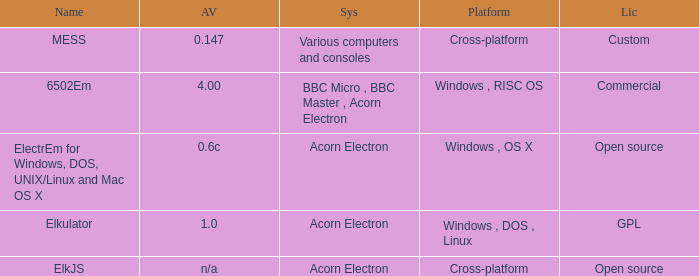Write the full table. {'header': ['Name', 'AV', 'Sys', 'Platform', 'Lic'], 'rows': [['MESS', '0.147', 'Various computers and consoles', 'Cross-platform', 'Custom'], ['6502Em', '4.00', 'BBC Micro , BBC Master , Acorn Electron', 'Windows , RISC OS', 'Commercial'], ['ElectrEm for Windows, DOS, UNIX/Linux and Mac OS X', '0.6c', 'Acorn Electron', 'Windows , OS X', 'Open source'], ['Elkulator', '1.0', 'Acorn Electron', 'Windows , DOS , Linux', 'GPL'], ['ElkJS', 'n/a', 'Acorn Electron', 'Cross-platform', 'Open source']]} What is the designation of the platform employed for various computers and consoles? Cross-platform. 